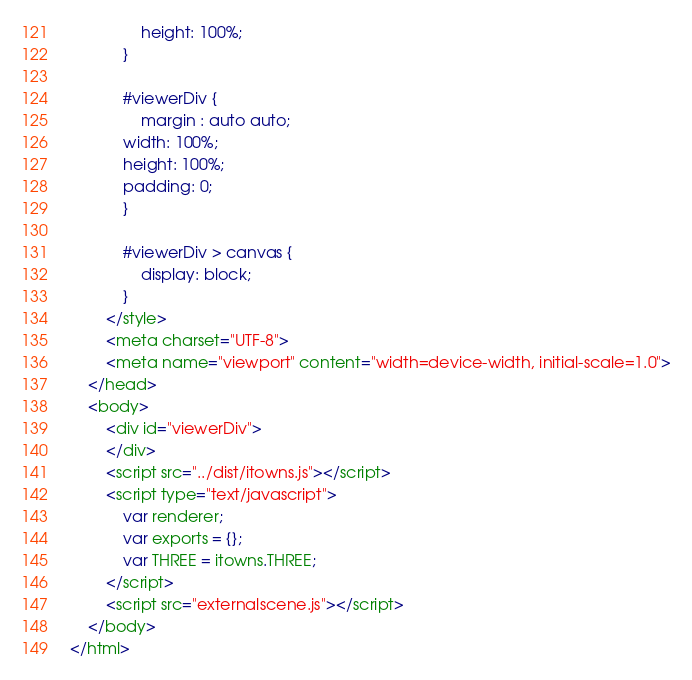<code> <loc_0><loc_0><loc_500><loc_500><_HTML_>                height: 100%;
            }

            #viewerDiv {
                margin : auto auto;
            width: 100%;
            height: 100%;
            padding: 0;
            }

            #viewerDiv > canvas {
                display: block;
            }
        </style>
        <meta charset="UTF-8">
        <meta name="viewport" content="width=device-width, initial-scale=1.0">
    </head>
    <body>
        <div id="viewerDiv">
        </div>
        <script src="../dist/itowns.js"></script>
        <script type="text/javascript">
            var renderer;
            var exports = {};
            var THREE = itowns.THREE;
        </script>
        <script src="externalscene.js"></script>
    </body>
</html>
</code> 